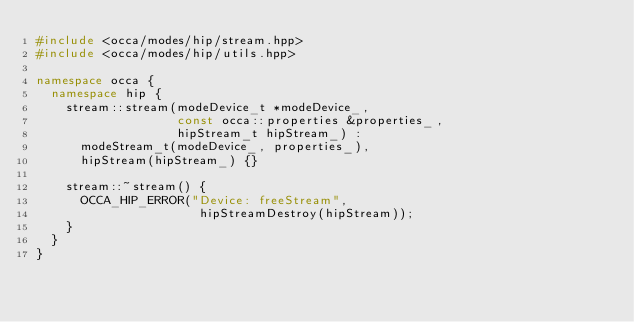<code> <loc_0><loc_0><loc_500><loc_500><_C++_>#include <occa/modes/hip/stream.hpp>
#include <occa/modes/hip/utils.hpp>

namespace occa {
  namespace hip {
    stream::stream(modeDevice_t *modeDevice_,
                   const occa::properties &properties_,
                   hipStream_t hipStream_) :
      modeStream_t(modeDevice_, properties_),
      hipStream(hipStream_) {}

    stream::~stream() {
      OCCA_HIP_ERROR("Device: freeStream",
                      hipStreamDestroy(hipStream));
    }
  }
}
</code> 